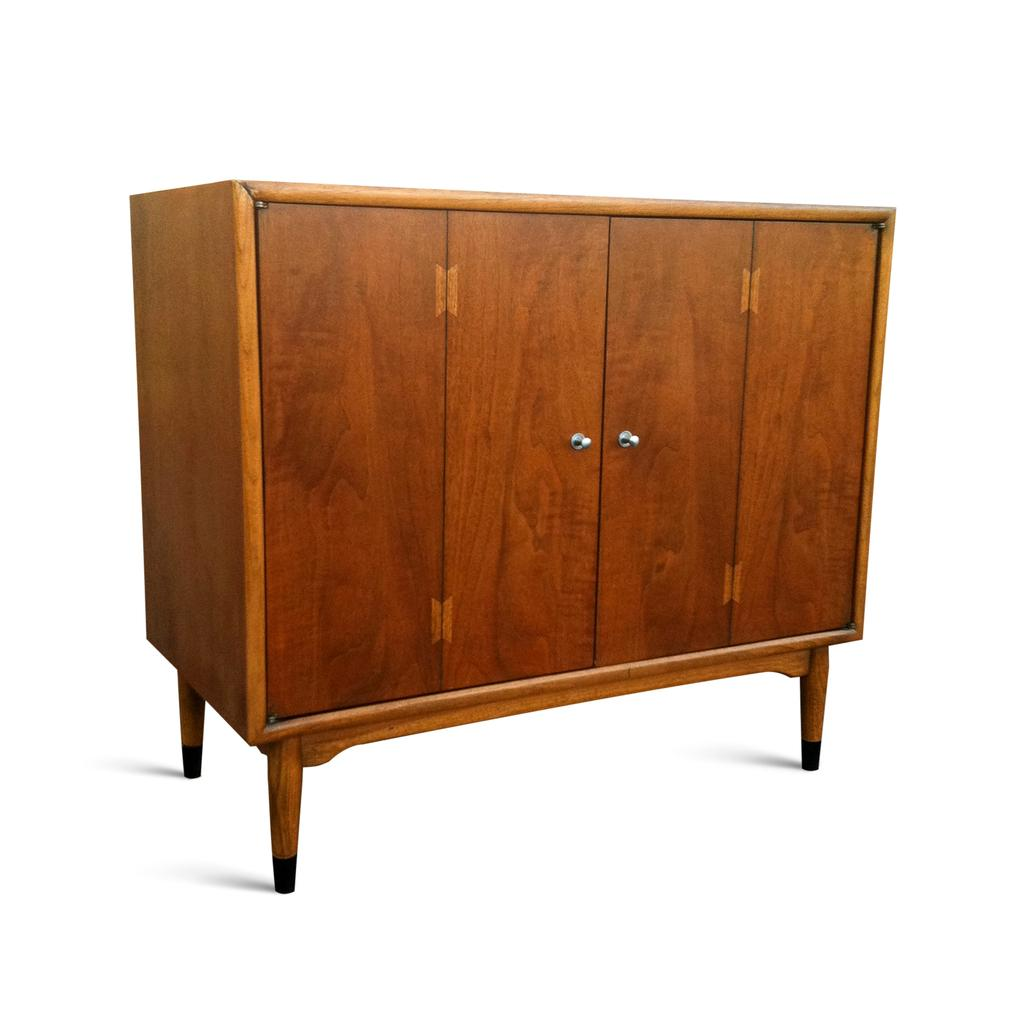What type of furniture is present in the image? There is a cupboard in the image. What color is the background of the image? The background of the image is white. Are there any cobwebs visible in the image? There is no mention of cobwebs in the provided facts, so we cannot determine their presence from the image. 